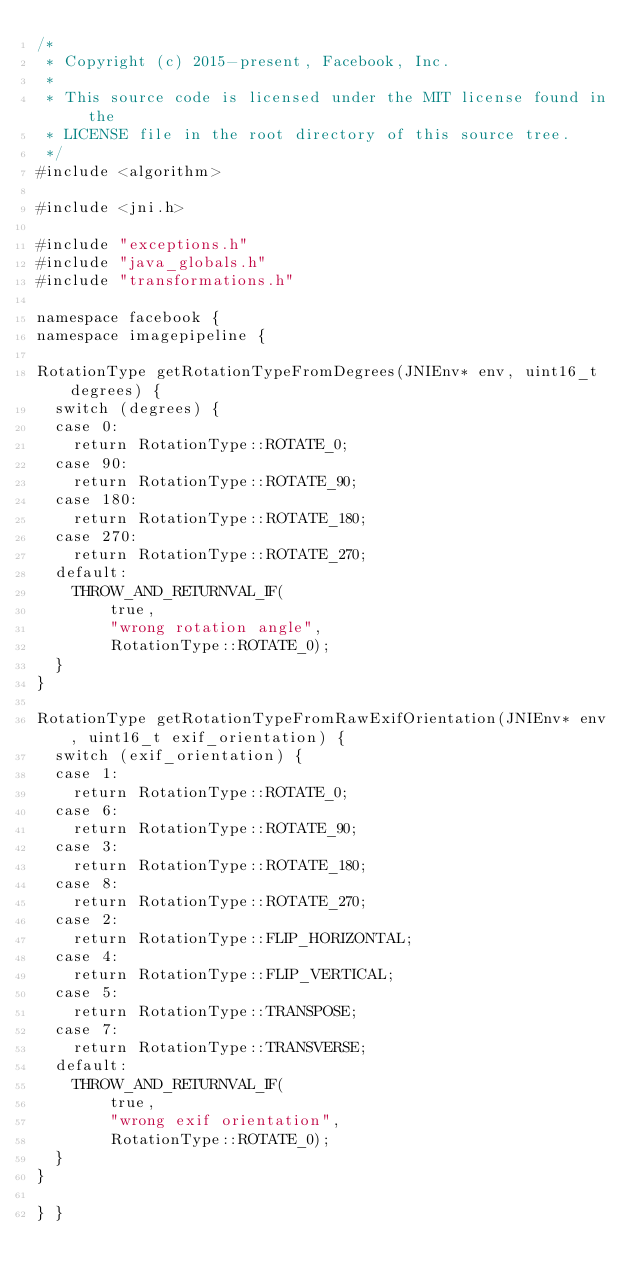<code> <loc_0><loc_0><loc_500><loc_500><_C++_>/*
 * Copyright (c) 2015-present, Facebook, Inc.
 *
 * This source code is licensed under the MIT license found in the
 * LICENSE file in the root directory of this source tree.
 */
#include <algorithm>

#include <jni.h>

#include "exceptions.h"
#include "java_globals.h"
#include "transformations.h"

namespace facebook {
namespace imagepipeline {

RotationType getRotationTypeFromDegrees(JNIEnv* env, uint16_t degrees) {
  switch (degrees) {
  case 0:
    return RotationType::ROTATE_0;
  case 90:
    return RotationType::ROTATE_90;
  case 180:
    return RotationType::ROTATE_180;
  case 270:
    return RotationType::ROTATE_270;
  default:
    THROW_AND_RETURNVAL_IF(
        true,
        "wrong rotation angle",
        RotationType::ROTATE_0);
  }
}

RotationType getRotationTypeFromRawExifOrientation(JNIEnv* env, uint16_t exif_orientation) {
  switch (exif_orientation) {
  case 1:
    return RotationType::ROTATE_0;
  case 6:
    return RotationType::ROTATE_90;
  case 3:
    return RotationType::ROTATE_180;
  case 8:
    return RotationType::ROTATE_270;
  case 2:
    return RotationType::FLIP_HORIZONTAL;
  case 4:
    return RotationType::FLIP_VERTICAL;
  case 5:
    return RotationType::TRANSPOSE;
  case 7:
    return RotationType::TRANSVERSE;
  default:
    THROW_AND_RETURNVAL_IF(
        true,
        "wrong exif orientation",
        RotationType::ROTATE_0);
  }
}

} }
</code> 